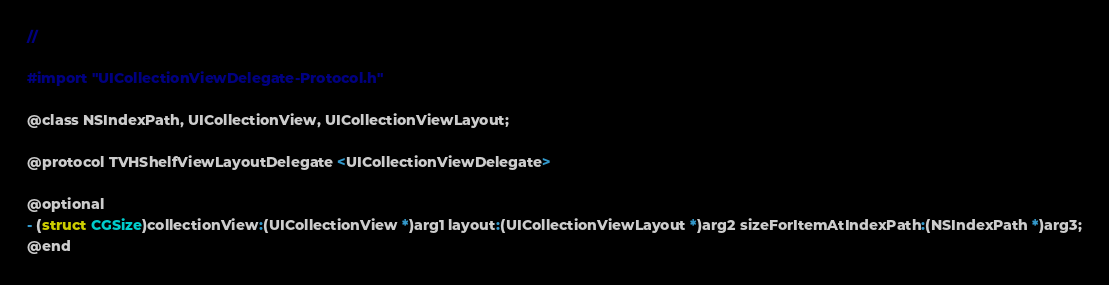<code> <loc_0><loc_0><loc_500><loc_500><_C_>//

#import "UICollectionViewDelegate-Protocol.h"

@class NSIndexPath, UICollectionView, UICollectionViewLayout;

@protocol TVHShelfViewLayoutDelegate <UICollectionViewDelegate>

@optional
- (struct CGSize)collectionView:(UICollectionView *)arg1 layout:(UICollectionViewLayout *)arg2 sizeForItemAtIndexPath:(NSIndexPath *)arg3;
@end

</code> 